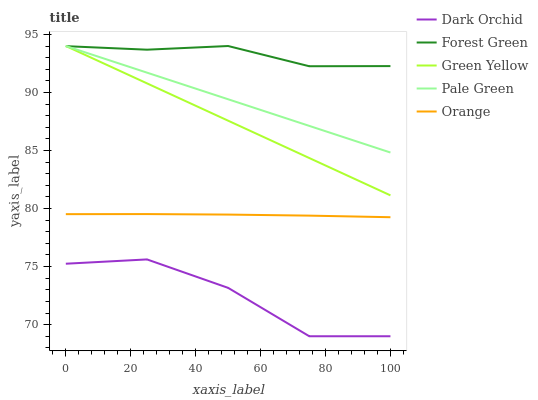Does Dark Orchid have the minimum area under the curve?
Answer yes or no. Yes. Does Forest Green have the maximum area under the curve?
Answer yes or no. Yes. Does Pale Green have the minimum area under the curve?
Answer yes or no. No. Does Pale Green have the maximum area under the curve?
Answer yes or no. No. Is Green Yellow the smoothest?
Answer yes or no. Yes. Is Dark Orchid the roughest?
Answer yes or no. Yes. Is Pale Green the smoothest?
Answer yes or no. No. Is Pale Green the roughest?
Answer yes or no. No. Does Dark Orchid have the lowest value?
Answer yes or no. Yes. Does Pale Green have the lowest value?
Answer yes or no. No. Does Green Yellow have the highest value?
Answer yes or no. Yes. Does Dark Orchid have the highest value?
Answer yes or no. No. Is Dark Orchid less than Forest Green?
Answer yes or no. Yes. Is Pale Green greater than Orange?
Answer yes or no. Yes. Does Pale Green intersect Green Yellow?
Answer yes or no. Yes. Is Pale Green less than Green Yellow?
Answer yes or no. No. Is Pale Green greater than Green Yellow?
Answer yes or no. No. Does Dark Orchid intersect Forest Green?
Answer yes or no. No. 